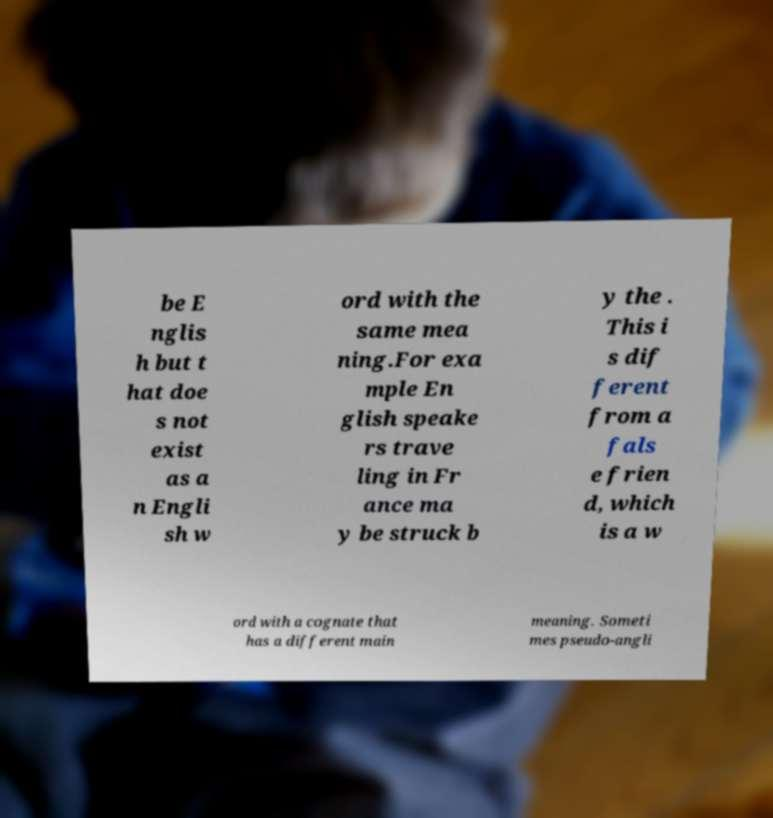Please read and relay the text visible in this image. What does it say? be E nglis h but t hat doe s not exist as a n Engli sh w ord with the same mea ning.For exa mple En glish speake rs trave ling in Fr ance ma y be struck b y the . This i s dif ferent from a fals e frien d, which is a w ord with a cognate that has a different main meaning. Someti mes pseudo-angli 